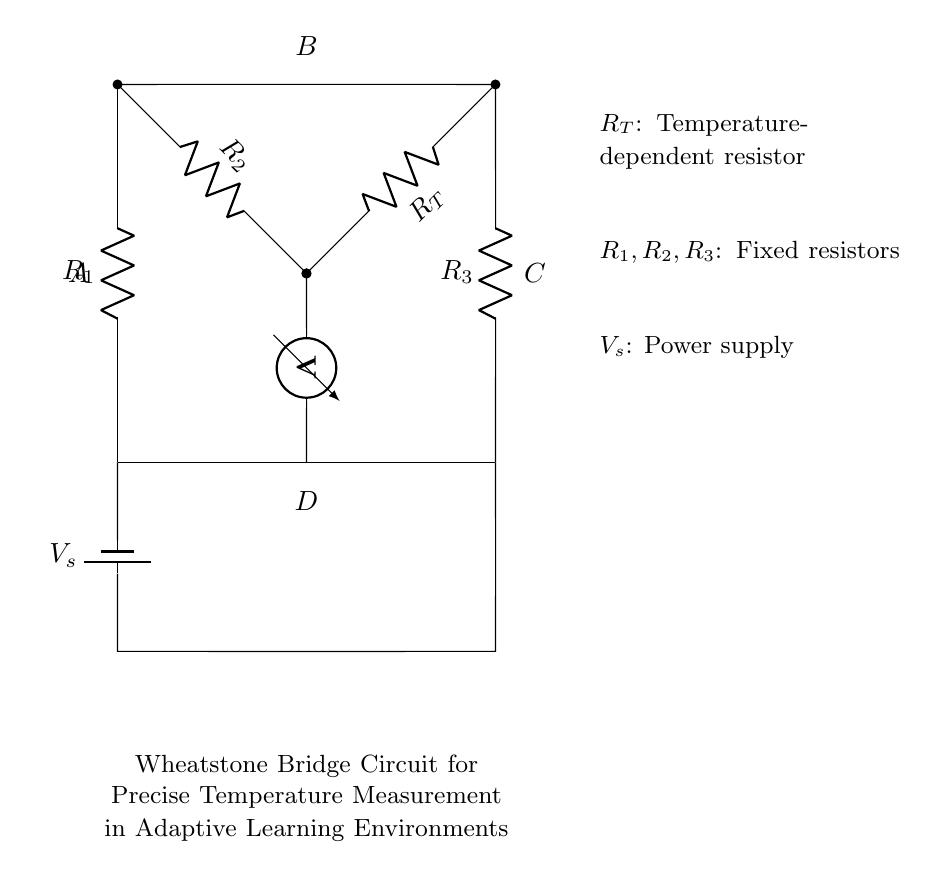What type of resistors are used in this circuit? The diagram shows three fixed resistors labeled as R1, R2, and R3, along with one temperature-dependent resistor labeled as RT.
Answer: Fixed and temperature-dependent What is the function of the voltmeter in the circuit? The voltmeter is connected across the output terminals to measure the voltage (potential difference) between points D and B, indicating the balance of the bridge.
Answer: Measure voltage Which component represents the power supply? The component labeled as Vs in the circuit indicates the power supply, providing the necessary voltage to the Wheatstone bridge for operation.
Answer: Vs What happens to the output voltage if the temperature changes? If the temperature changes, the resistance of RT will change, leading to an imbalance in the bridge, thereby changing the output voltage measured across the voltmeter.
Answer: Changes the output voltage How many resistors are in the Wheatstone bridge circuit? There are a total of four resistors shown in the circuit: three fixed resistors (R1, R2, R3) and one temperature-dependent resistor (RT).
Answer: Four resistors What is the purpose of the Wheatstone bridge in this context? The Wheatstone bridge is utilized for precise temperature measurement by detecting changes in resistance as the temperature varies, which is important for adaptive learning environments.
Answer: Precise temperature measurement 